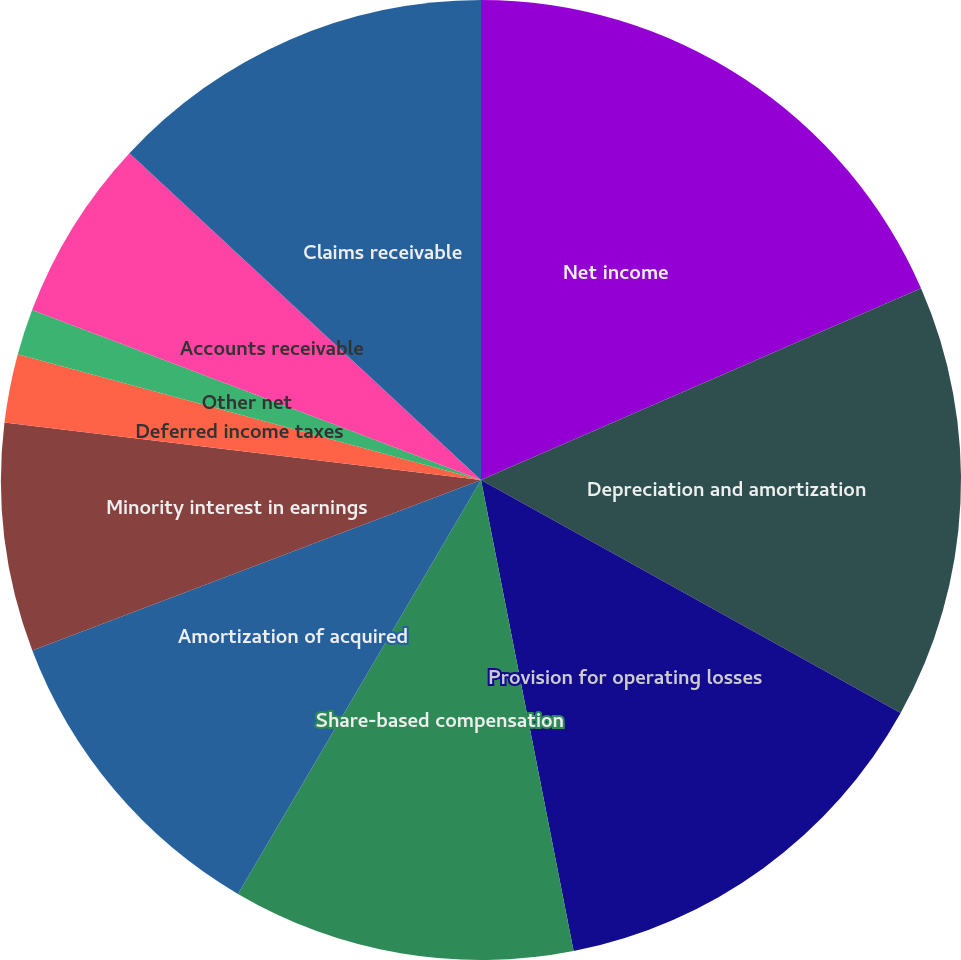Convert chart. <chart><loc_0><loc_0><loc_500><loc_500><pie_chart><fcel>Net income<fcel>Depreciation and amortization<fcel>Provision for operating losses<fcel>Share-based compensation<fcel>Amortization of acquired<fcel>Minority interest in earnings<fcel>Deferred income taxes<fcel>Other net<fcel>Accounts receivable<fcel>Claims receivable<nl><fcel>18.46%<fcel>14.61%<fcel>13.84%<fcel>11.54%<fcel>10.77%<fcel>7.69%<fcel>2.31%<fcel>1.54%<fcel>6.16%<fcel>13.08%<nl></chart> 